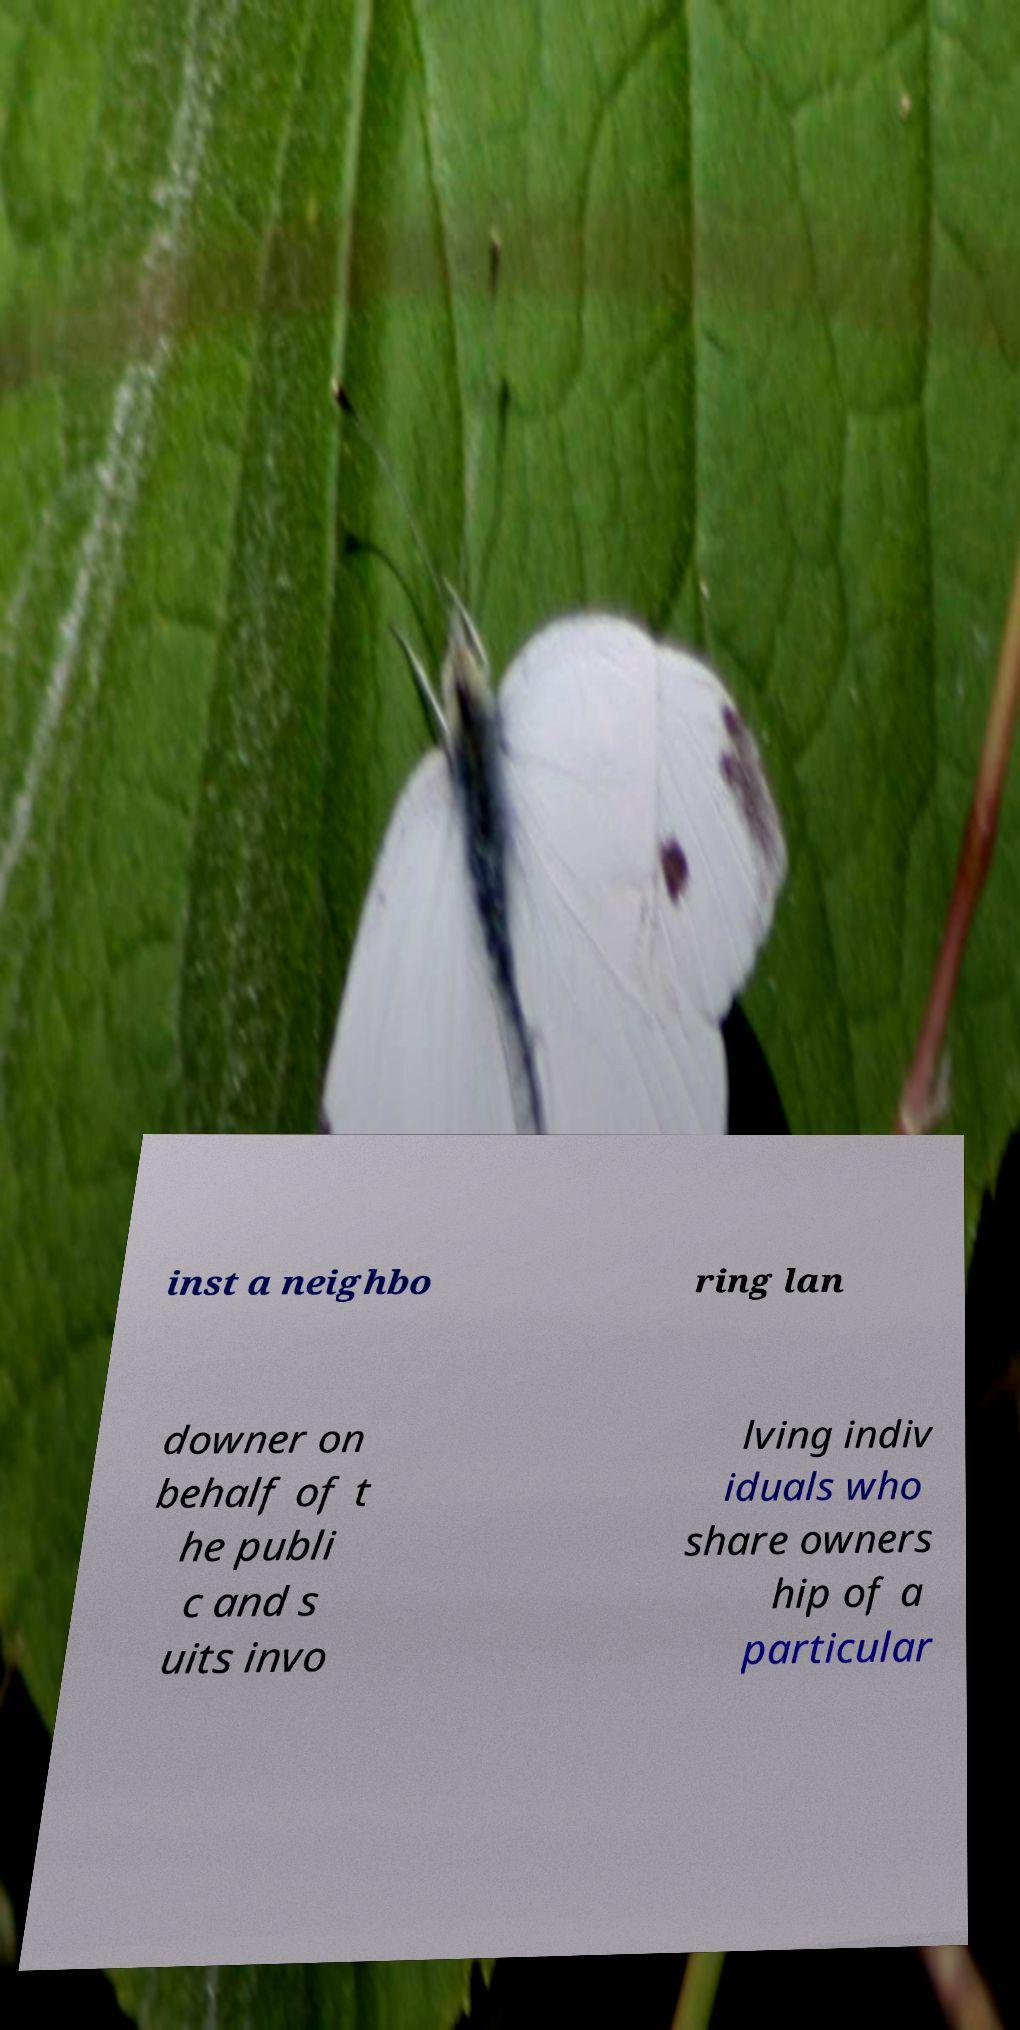Can you accurately transcribe the text from the provided image for me? inst a neighbo ring lan downer on behalf of t he publi c and s uits invo lving indiv iduals who share owners hip of a particular 